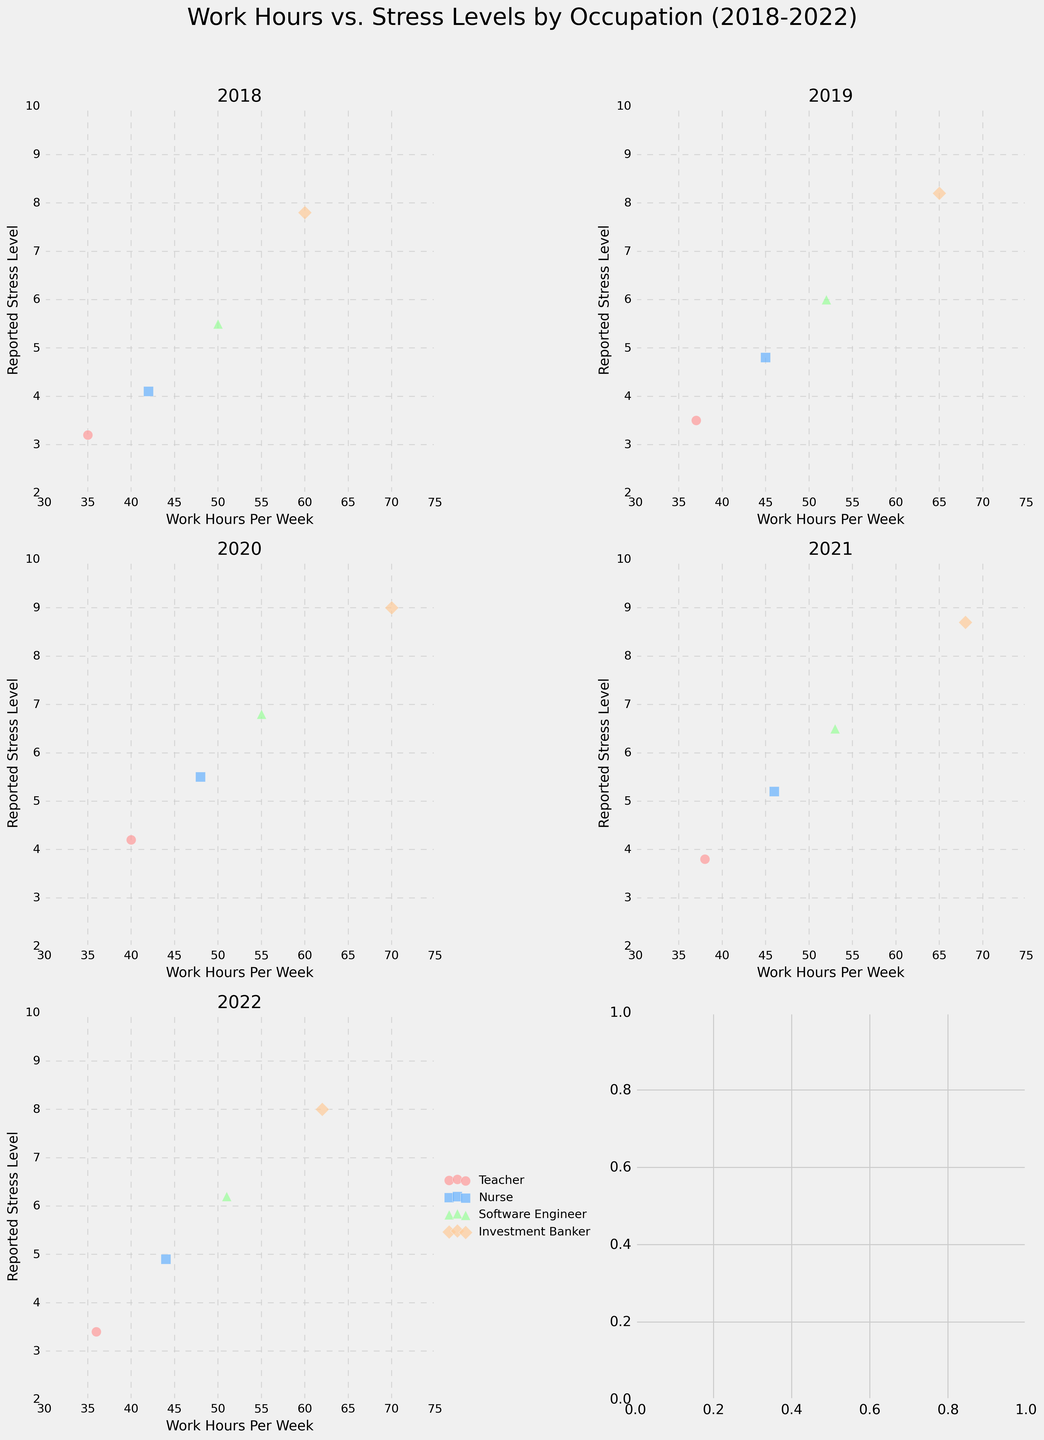What is the title of the plot? The title of the plot is typically placed at the top of the figure and often provides a summary or main idea of what the plot represents. In this case, the title is "Work Hours vs. Stress Levels by Occupation (2018-2022)" as stated in the code.
Answer: Work Hours vs. Stress Levels by Occupation (2018-2022) How did the reported stress levels of teachers change from 2018 to 2022? We need to look at the scatter points for the 'Teacher' occupation across all subplots from 2018 to 2022 and observe the reported stress levels. In 2018, stress level was 3.2, and in 2022 it was 3.4.
Answer: Increased slightly Which occupation had the highest reported stress level in 2020? To determine this, we look at the scatter plot for the year 2020 and identify the highest y-value (stress level) among all the occupations. The Investment Banker occupation had the highest reported stress level at 9.0.
Answer: Investment Banker Compare the work hours per week for Software Engineers between 2018 and 2021. What trend do you observe? Reviewing the scatter plot for Software Engineers between 2018 and 2021, we see 50 hours in 2018, 52 in 2019, 55 in 2020, and 53 in 2021. The trend indicates a slight increase from 2018 to 2020, then a small decrease in 2021.
Answer: Slight increase then slight decrease What is the range of reported stress levels for nurses in 2019? To find the range, we look at the nurse data points in the 2019 subplot. The reported stress levels were 4.8 and 4.8. Hence, the range is 4.8 - 4.1 = 4.8 - 4.1 = 0.7.
Answer: 0.7 What was the average reported stress level for Investment Bankers over the 5-year period? We need to identify the stress levels for Investment Bankers across all years: 7.8 (2018), 8.2 (2019), 9.0 (2020), 8.7 (2021), 8.0 (2022). The average is (7.8 + 8.2 + 9.0 + 8.7 + 8.0) / 5 = 41.7 / 5
Answer: 8.34 